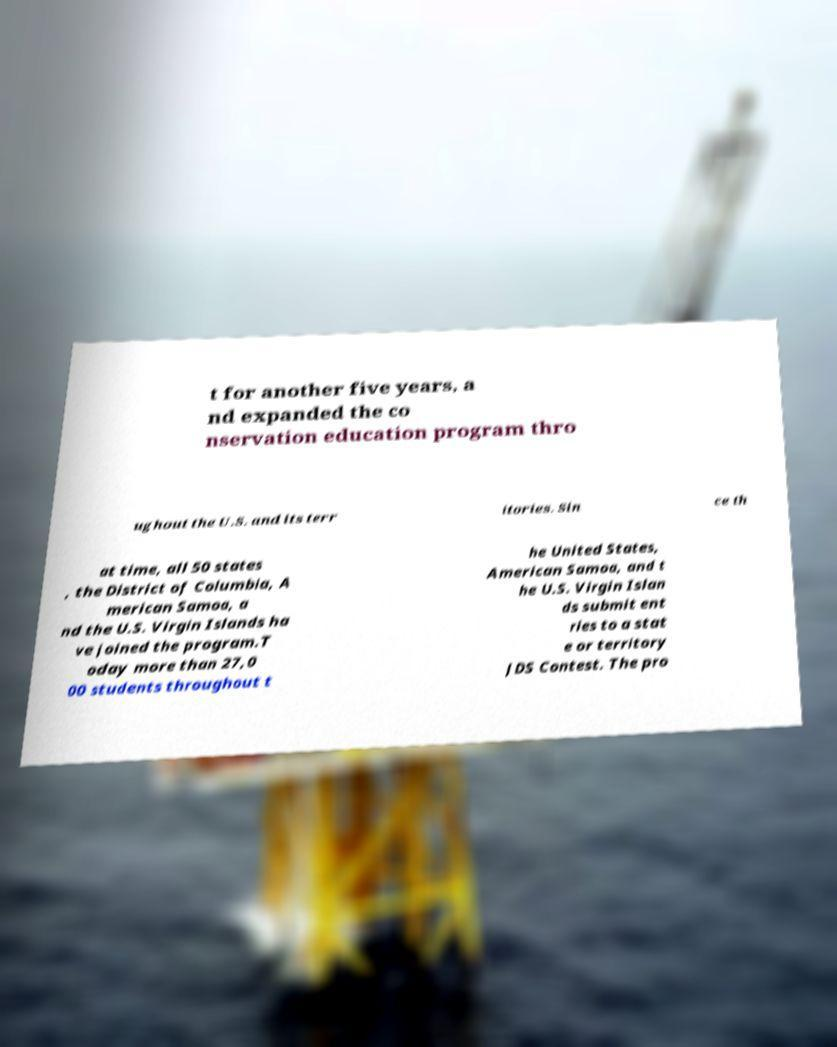Could you assist in decoding the text presented in this image and type it out clearly? t for another five years, a nd expanded the co nservation education program thro ughout the U.S. and its terr itories. Sin ce th at time, all 50 states , the District of Columbia, A merican Samoa, a nd the U.S. Virgin Islands ha ve joined the program.T oday more than 27,0 00 students throughout t he United States, American Samoa, and t he U.S. Virgin Islan ds submit ent ries to a stat e or territory JDS Contest. The pro 